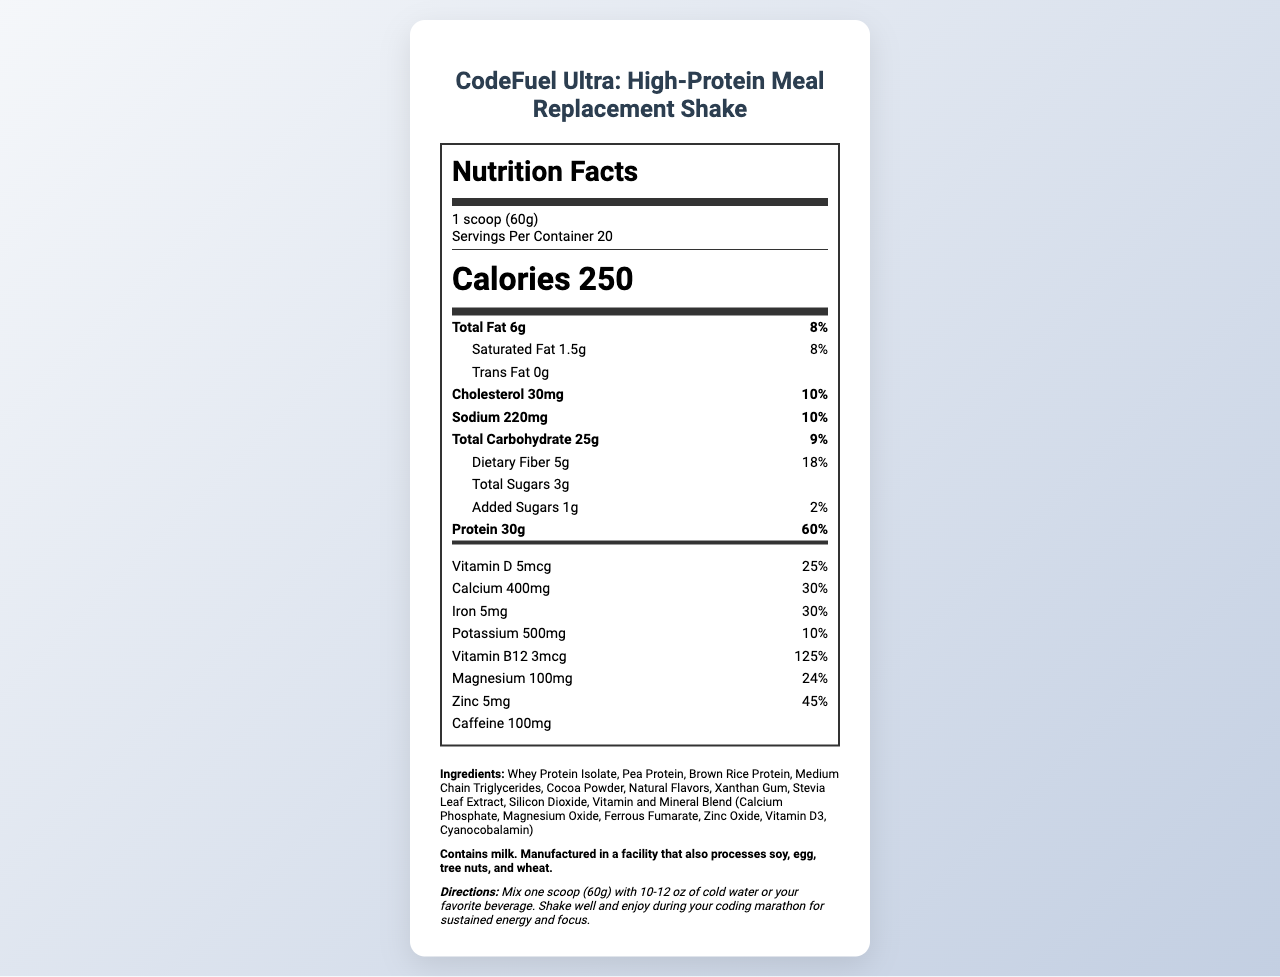What is the serving size for CodeFuel Ultra shake? The serving size is indicated as "1 scoop (60g)" under the serving information section.
Answer: 1 scoop (60g) How many calories are in one serving of the shake? The calorie count per serving is listed as 250 in the calories section.
Answer: 250 How much protein does each serving contain? The amount of protein per serving is detailed as 30g within the main nutrient data.
Answer: 30g What is the amount of dietary fiber per serving? Dietary fiber is noted to be 5g per serving under the dietary fiber section.
Answer: 5g Does the shake contain any caffeine? The document specifies that each serving contains 100mg of caffeine.
Answer: Yes How much calcium is in each serving? A. 200mg B. 300mg C. 400mg The amount of calcium per serving is listed as 400mg in the vitamins and minerals section.
Answer: C What percentage of the daily value of Vitamin B12 does one serving contain? A. 25% B. 100% C. 125% One serving contains 125% of the daily value of Vitamin B12 which is stated in the vitamins section.
Answer: C Is there any trans fat in the shake? The document specifically notes "Trans Fat 0g".
Answer: No What is the total carbohydrate content per serving? The total carbohydrate content per serving is indicated as 25g in the main nutrient section.
Answer: 25g What is the largest nutrient percentage of daily value provided by the shake? The shake provides 125% of the daily value for Vitamin B12, which is the highest percentage listed.
Answer: Vitamin B12 Summarize the main idea of the document. The summary captures the primary aspects of the document, which includes detailed nutrition facts along with ingredients and usage instructions tailored for prolonged focus and energy, suitable for coding marathons.
Answer: The document provides nutritional information for the CodeFuel Ultra: High-Protein Meal Replacement Shake. It includes serving size, calorie count, specific nutrient amounts, ingredient list, allergen information, and usage directions. The shake is designed to support sustained energy and focus during coding marathons with high protein, fiber, various vitamins, and minerals. What is the primary ingredient in the shake? The first ingredient listed is Whey Protein Isolate, indicating it is the primary ingredient.
Answer: Whey Protein Isolate What does the allergen information state? The allergen information specifically mentions that the product contains milk and is processed in a facility handling several other allergens.
Answer: Contains milk. Manufactured in a facility that also processes soy, egg, tree nuts, and wheat. What are the storage instructions for the shake? These instructions are given towards the end of the document.
Answer: Store in a cool, dry place. Seal tightly after opening. How many servings are there per container? The serving information states there are 20 servings per container.
Answer: 20 Can we determine the price of the shake from the document? The document does not provide any pricing information, focusing solely on nutritional facts and related details.
Answer: Cannot be determined 